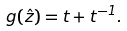Convert formula to latex. <formula><loc_0><loc_0><loc_500><loc_500>g ( \hat { z } ) = t + t ^ { - 1 } .</formula> 